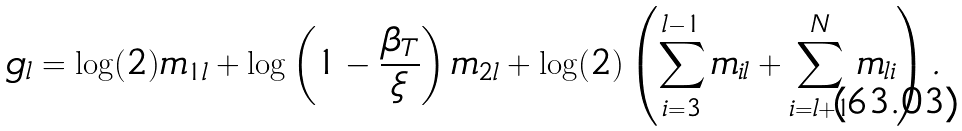Convert formula to latex. <formula><loc_0><loc_0><loc_500><loc_500>g _ { l } & = \log ( 2 ) m _ { 1 l } + \log \left ( 1 - \frac { \beta _ { T } } { \xi } \right ) m _ { 2 l } + \log ( 2 ) \left ( \sum ^ { l - 1 } _ { i = 3 } m _ { i l } + \sum ^ { N } _ { i = l + 1 } m _ { l i } \right ) .</formula> 